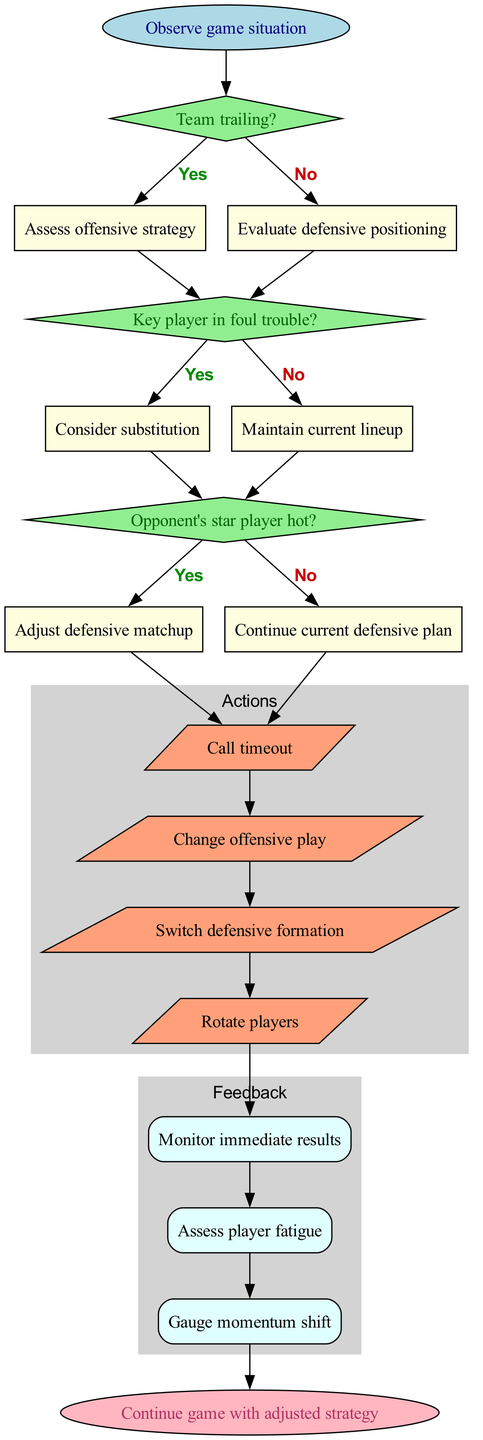What is the first step in the flowchart? The flowchart begins with the action to "Observe game situation," which sets the stage for the decision-making process.
Answer: Observe game situation How many decisions are present in the flowchart? There are three decision nodes outlined in the diagram, each focusing on a specific game situation that informs potential actions.
Answer: 3 What action is taken if the team is trailing and the key player is not in foul trouble? If the team is trailing, the flowchart instructs to "Assess offensive strategy." After that decision, if the key player is not in foul trouble, it suggests to "Maintain current lineup." Thus, the next action remains focused on assessing the offense.
Answer: Assess offensive strategy What is the last action node in the flowchart? The final action node listed in the diagram is "Rotate players," which indicates it is the last consideration for adjustment before moving to the feedback stage.
Answer: Rotate players What happens if the opponent's star player is hot? If the opponent's star player is hot, the flowchart dictates to "Adjust defensive matchup," which leads to the next steps in action and feedback.
Answer: Adjust defensive matchup How is player fatigue assessed? Player fatigue is assessed through a feedback node that follows after various actions lead to evaluating the game's outcome, indicating the importance of monitoring player condition.
Answer: Assess player fatigue 